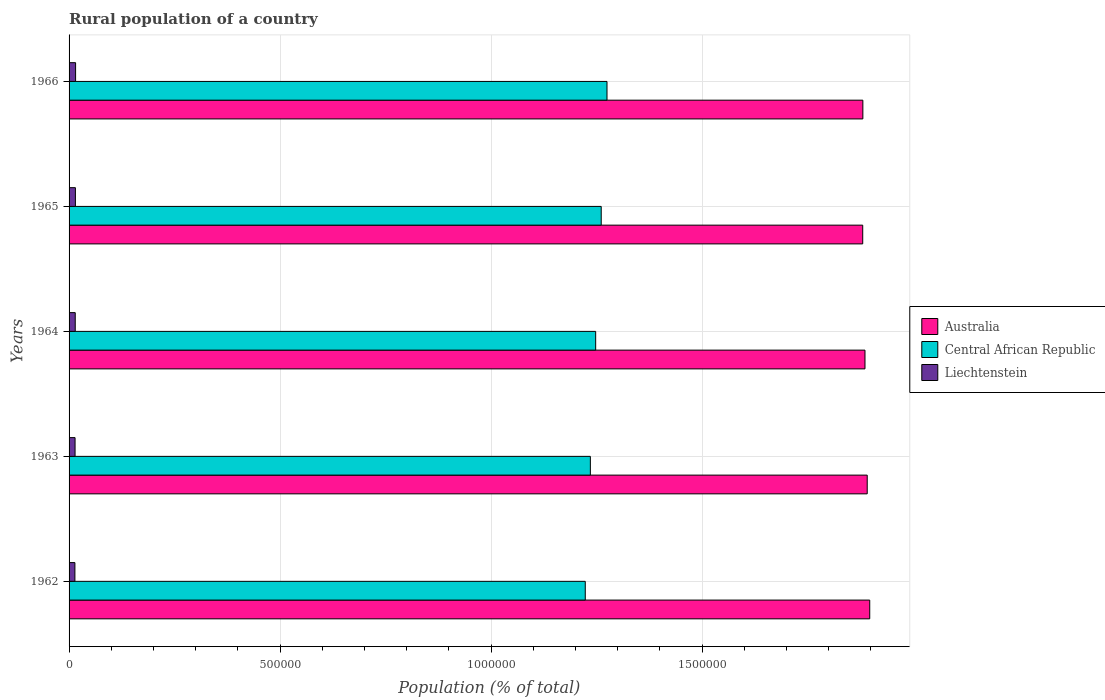How many different coloured bars are there?
Your response must be concise. 3. Are the number of bars per tick equal to the number of legend labels?
Ensure brevity in your answer.  Yes. How many bars are there on the 3rd tick from the bottom?
Your answer should be compact. 3. What is the label of the 2nd group of bars from the top?
Make the answer very short. 1965. In how many cases, is the number of bars for a given year not equal to the number of legend labels?
Offer a very short reply. 0. What is the rural population in Australia in 1966?
Ensure brevity in your answer.  1.88e+06. Across all years, what is the maximum rural population in Central African Republic?
Provide a short and direct response. 1.27e+06. Across all years, what is the minimum rural population in Central African Republic?
Your answer should be compact. 1.22e+06. In which year was the rural population in Central African Republic maximum?
Offer a terse response. 1966. In which year was the rural population in Australia minimum?
Provide a short and direct response. 1965. What is the total rural population in Australia in the graph?
Give a very brief answer. 9.44e+06. What is the difference between the rural population in Central African Republic in 1962 and that in 1966?
Ensure brevity in your answer.  -5.15e+04. What is the difference between the rural population in Liechtenstein in 1966 and the rural population in Australia in 1962?
Your answer should be very brief. -1.88e+06. What is the average rural population in Australia per year?
Keep it short and to the point. 1.89e+06. In the year 1965, what is the difference between the rural population in Australia and rural population in Central African Republic?
Give a very brief answer. 6.20e+05. What is the ratio of the rural population in Central African Republic in 1962 to that in 1965?
Keep it short and to the point. 0.97. Is the rural population in Australia in 1964 less than that in 1965?
Make the answer very short. No. What is the difference between the highest and the second highest rural population in Liechtenstein?
Give a very brief answer. 450. What is the difference between the highest and the lowest rural population in Liechtenstein?
Offer a very short reply. 1645. In how many years, is the rural population in Liechtenstein greater than the average rural population in Liechtenstein taken over all years?
Your answer should be compact. 2. What does the 2nd bar from the top in 1966 represents?
Provide a succinct answer. Central African Republic. What does the 3rd bar from the bottom in 1965 represents?
Make the answer very short. Liechtenstein. How many bars are there?
Give a very brief answer. 15. Are the values on the major ticks of X-axis written in scientific E-notation?
Give a very brief answer. No. Does the graph contain any zero values?
Offer a terse response. No. Does the graph contain grids?
Provide a succinct answer. Yes. Where does the legend appear in the graph?
Provide a succinct answer. Center right. How many legend labels are there?
Your answer should be very brief. 3. How are the legend labels stacked?
Offer a terse response. Vertical. What is the title of the graph?
Make the answer very short. Rural population of a country. Does "Uzbekistan" appear as one of the legend labels in the graph?
Your answer should be very brief. No. What is the label or title of the X-axis?
Give a very brief answer. Population (% of total). What is the Population (% of total) in Australia in 1962?
Ensure brevity in your answer.  1.90e+06. What is the Population (% of total) of Central African Republic in 1962?
Ensure brevity in your answer.  1.22e+06. What is the Population (% of total) in Liechtenstein in 1962?
Offer a very short reply. 1.38e+04. What is the Population (% of total) of Australia in 1963?
Your response must be concise. 1.89e+06. What is the Population (% of total) in Central African Republic in 1963?
Your response must be concise. 1.24e+06. What is the Population (% of total) of Liechtenstein in 1963?
Keep it short and to the point. 1.42e+04. What is the Population (% of total) of Australia in 1964?
Make the answer very short. 1.89e+06. What is the Population (% of total) of Central African Republic in 1964?
Provide a succinct answer. 1.25e+06. What is the Population (% of total) in Liechtenstein in 1964?
Your answer should be compact. 1.46e+04. What is the Population (% of total) of Australia in 1965?
Provide a short and direct response. 1.88e+06. What is the Population (% of total) of Central African Republic in 1965?
Provide a short and direct response. 1.26e+06. What is the Population (% of total) in Liechtenstein in 1965?
Offer a very short reply. 1.50e+04. What is the Population (% of total) of Australia in 1966?
Your answer should be compact. 1.88e+06. What is the Population (% of total) in Central African Republic in 1966?
Provide a succinct answer. 1.27e+06. What is the Population (% of total) of Liechtenstein in 1966?
Offer a very short reply. 1.55e+04. Across all years, what is the maximum Population (% of total) of Australia?
Ensure brevity in your answer.  1.90e+06. Across all years, what is the maximum Population (% of total) in Central African Republic?
Offer a terse response. 1.27e+06. Across all years, what is the maximum Population (% of total) in Liechtenstein?
Offer a very short reply. 1.55e+04. Across all years, what is the minimum Population (% of total) of Australia?
Your response must be concise. 1.88e+06. Across all years, what is the minimum Population (% of total) in Central African Republic?
Your answer should be compact. 1.22e+06. Across all years, what is the minimum Population (% of total) of Liechtenstein?
Your answer should be very brief. 1.38e+04. What is the total Population (% of total) in Australia in the graph?
Offer a very short reply. 9.44e+06. What is the total Population (% of total) in Central African Republic in the graph?
Your response must be concise. 6.24e+06. What is the total Population (% of total) of Liechtenstein in the graph?
Your response must be concise. 7.31e+04. What is the difference between the Population (% of total) of Australia in 1962 and that in 1963?
Your answer should be very brief. 5966. What is the difference between the Population (% of total) of Central African Republic in 1962 and that in 1963?
Provide a short and direct response. -1.21e+04. What is the difference between the Population (% of total) in Liechtenstein in 1962 and that in 1963?
Your answer should be compact. -376. What is the difference between the Population (% of total) in Australia in 1962 and that in 1964?
Your response must be concise. 1.13e+04. What is the difference between the Population (% of total) of Central African Republic in 1962 and that in 1964?
Make the answer very short. -2.46e+04. What is the difference between the Population (% of total) of Liechtenstein in 1962 and that in 1964?
Offer a very short reply. -773. What is the difference between the Population (% of total) of Australia in 1962 and that in 1965?
Your response must be concise. 1.66e+04. What is the difference between the Population (% of total) in Central African Republic in 1962 and that in 1965?
Provide a short and direct response. -3.78e+04. What is the difference between the Population (% of total) of Liechtenstein in 1962 and that in 1965?
Your answer should be very brief. -1195. What is the difference between the Population (% of total) of Australia in 1962 and that in 1966?
Ensure brevity in your answer.  1.63e+04. What is the difference between the Population (% of total) of Central African Republic in 1962 and that in 1966?
Your response must be concise. -5.15e+04. What is the difference between the Population (% of total) in Liechtenstein in 1962 and that in 1966?
Ensure brevity in your answer.  -1645. What is the difference between the Population (% of total) in Australia in 1963 and that in 1964?
Provide a succinct answer. 5287. What is the difference between the Population (% of total) of Central African Republic in 1963 and that in 1964?
Your answer should be very brief. -1.26e+04. What is the difference between the Population (% of total) of Liechtenstein in 1963 and that in 1964?
Your answer should be very brief. -397. What is the difference between the Population (% of total) of Australia in 1963 and that in 1965?
Ensure brevity in your answer.  1.07e+04. What is the difference between the Population (% of total) in Central African Republic in 1963 and that in 1965?
Offer a very short reply. -2.57e+04. What is the difference between the Population (% of total) in Liechtenstein in 1963 and that in 1965?
Provide a succinct answer. -819. What is the difference between the Population (% of total) of Australia in 1963 and that in 1966?
Ensure brevity in your answer.  1.03e+04. What is the difference between the Population (% of total) in Central African Republic in 1963 and that in 1966?
Provide a short and direct response. -3.94e+04. What is the difference between the Population (% of total) of Liechtenstein in 1963 and that in 1966?
Your response must be concise. -1269. What is the difference between the Population (% of total) of Australia in 1964 and that in 1965?
Offer a terse response. 5378. What is the difference between the Population (% of total) of Central African Republic in 1964 and that in 1965?
Make the answer very short. -1.31e+04. What is the difference between the Population (% of total) in Liechtenstein in 1964 and that in 1965?
Keep it short and to the point. -422. What is the difference between the Population (% of total) in Australia in 1964 and that in 1966?
Provide a short and direct response. 5052. What is the difference between the Population (% of total) in Central African Republic in 1964 and that in 1966?
Give a very brief answer. -2.68e+04. What is the difference between the Population (% of total) of Liechtenstein in 1964 and that in 1966?
Provide a short and direct response. -872. What is the difference between the Population (% of total) in Australia in 1965 and that in 1966?
Your answer should be very brief. -326. What is the difference between the Population (% of total) of Central African Republic in 1965 and that in 1966?
Your answer should be very brief. -1.37e+04. What is the difference between the Population (% of total) of Liechtenstein in 1965 and that in 1966?
Keep it short and to the point. -450. What is the difference between the Population (% of total) in Australia in 1962 and the Population (% of total) in Central African Republic in 1963?
Make the answer very short. 6.62e+05. What is the difference between the Population (% of total) of Australia in 1962 and the Population (% of total) of Liechtenstein in 1963?
Your answer should be compact. 1.88e+06. What is the difference between the Population (% of total) in Central African Republic in 1962 and the Population (% of total) in Liechtenstein in 1963?
Your answer should be compact. 1.21e+06. What is the difference between the Population (% of total) of Australia in 1962 and the Population (% of total) of Central African Republic in 1964?
Make the answer very short. 6.49e+05. What is the difference between the Population (% of total) of Australia in 1962 and the Population (% of total) of Liechtenstein in 1964?
Provide a short and direct response. 1.88e+06. What is the difference between the Population (% of total) in Central African Republic in 1962 and the Population (% of total) in Liechtenstein in 1964?
Make the answer very short. 1.21e+06. What is the difference between the Population (% of total) in Australia in 1962 and the Population (% of total) in Central African Republic in 1965?
Your response must be concise. 6.36e+05. What is the difference between the Population (% of total) in Australia in 1962 and the Population (% of total) in Liechtenstein in 1965?
Ensure brevity in your answer.  1.88e+06. What is the difference between the Population (% of total) of Central African Republic in 1962 and the Population (% of total) of Liechtenstein in 1965?
Offer a very short reply. 1.21e+06. What is the difference between the Population (% of total) of Australia in 1962 and the Population (% of total) of Central African Republic in 1966?
Keep it short and to the point. 6.23e+05. What is the difference between the Population (% of total) in Australia in 1962 and the Population (% of total) in Liechtenstein in 1966?
Your answer should be very brief. 1.88e+06. What is the difference between the Population (% of total) of Central African Republic in 1962 and the Population (% of total) of Liechtenstein in 1966?
Offer a terse response. 1.21e+06. What is the difference between the Population (% of total) in Australia in 1963 and the Population (% of total) in Central African Republic in 1964?
Provide a succinct answer. 6.43e+05. What is the difference between the Population (% of total) of Australia in 1963 and the Population (% of total) of Liechtenstein in 1964?
Offer a terse response. 1.88e+06. What is the difference between the Population (% of total) of Central African Republic in 1963 and the Population (% of total) of Liechtenstein in 1964?
Ensure brevity in your answer.  1.22e+06. What is the difference between the Population (% of total) of Australia in 1963 and the Population (% of total) of Central African Republic in 1965?
Provide a short and direct response. 6.30e+05. What is the difference between the Population (% of total) of Australia in 1963 and the Population (% of total) of Liechtenstein in 1965?
Offer a terse response. 1.88e+06. What is the difference between the Population (% of total) in Central African Republic in 1963 and the Population (% of total) in Liechtenstein in 1965?
Offer a terse response. 1.22e+06. What is the difference between the Population (% of total) in Australia in 1963 and the Population (% of total) in Central African Republic in 1966?
Offer a terse response. 6.17e+05. What is the difference between the Population (% of total) of Australia in 1963 and the Population (% of total) of Liechtenstein in 1966?
Give a very brief answer. 1.88e+06. What is the difference between the Population (% of total) in Central African Republic in 1963 and the Population (% of total) in Liechtenstein in 1966?
Your response must be concise. 1.22e+06. What is the difference between the Population (% of total) of Australia in 1964 and the Population (% of total) of Central African Republic in 1965?
Your answer should be compact. 6.25e+05. What is the difference between the Population (% of total) of Australia in 1964 and the Population (% of total) of Liechtenstein in 1965?
Your answer should be compact. 1.87e+06. What is the difference between the Population (% of total) of Central African Republic in 1964 and the Population (% of total) of Liechtenstein in 1965?
Provide a succinct answer. 1.23e+06. What is the difference between the Population (% of total) in Australia in 1964 and the Population (% of total) in Central African Republic in 1966?
Provide a succinct answer. 6.11e+05. What is the difference between the Population (% of total) of Australia in 1964 and the Population (% of total) of Liechtenstein in 1966?
Your answer should be very brief. 1.87e+06. What is the difference between the Population (% of total) of Central African Republic in 1964 and the Population (% of total) of Liechtenstein in 1966?
Keep it short and to the point. 1.23e+06. What is the difference between the Population (% of total) of Australia in 1965 and the Population (% of total) of Central African Republic in 1966?
Provide a succinct answer. 6.06e+05. What is the difference between the Population (% of total) in Australia in 1965 and the Population (% of total) in Liechtenstein in 1966?
Your answer should be very brief. 1.87e+06. What is the difference between the Population (% of total) of Central African Republic in 1965 and the Population (% of total) of Liechtenstein in 1966?
Ensure brevity in your answer.  1.25e+06. What is the average Population (% of total) in Australia per year?
Your answer should be compact. 1.89e+06. What is the average Population (% of total) in Central African Republic per year?
Your answer should be compact. 1.25e+06. What is the average Population (% of total) in Liechtenstein per year?
Ensure brevity in your answer.  1.46e+04. In the year 1962, what is the difference between the Population (% of total) in Australia and Population (% of total) in Central African Republic?
Your response must be concise. 6.74e+05. In the year 1962, what is the difference between the Population (% of total) of Australia and Population (% of total) of Liechtenstein?
Ensure brevity in your answer.  1.88e+06. In the year 1962, what is the difference between the Population (% of total) in Central African Republic and Population (% of total) in Liechtenstein?
Provide a succinct answer. 1.21e+06. In the year 1963, what is the difference between the Population (% of total) in Australia and Population (% of total) in Central African Republic?
Keep it short and to the point. 6.56e+05. In the year 1963, what is the difference between the Population (% of total) in Australia and Population (% of total) in Liechtenstein?
Ensure brevity in your answer.  1.88e+06. In the year 1963, what is the difference between the Population (% of total) in Central African Republic and Population (% of total) in Liechtenstein?
Offer a very short reply. 1.22e+06. In the year 1964, what is the difference between the Population (% of total) of Australia and Population (% of total) of Central African Republic?
Make the answer very short. 6.38e+05. In the year 1964, what is the difference between the Population (% of total) of Australia and Population (% of total) of Liechtenstein?
Provide a short and direct response. 1.87e+06. In the year 1964, what is the difference between the Population (% of total) of Central African Republic and Population (% of total) of Liechtenstein?
Your response must be concise. 1.23e+06. In the year 1965, what is the difference between the Population (% of total) of Australia and Population (% of total) of Central African Republic?
Ensure brevity in your answer.  6.20e+05. In the year 1965, what is the difference between the Population (% of total) of Australia and Population (% of total) of Liechtenstein?
Keep it short and to the point. 1.87e+06. In the year 1965, what is the difference between the Population (% of total) in Central African Republic and Population (% of total) in Liechtenstein?
Provide a succinct answer. 1.25e+06. In the year 1966, what is the difference between the Population (% of total) of Australia and Population (% of total) of Central African Republic?
Your answer should be very brief. 6.06e+05. In the year 1966, what is the difference between the Population (% of total) of Australia and Population (% of total) of Liechtenstein?
Keep it short and to the point. 1.87e+06. In the year 1966, what is the difference between the Population (% of total) in Central African Republic and Population (% of total) in Liechtenstein?
Give a very brief answer. 1.26e+06. What is the ratio of the Population (% of total) of Australia in 1962 to that in 1963?
Make the answer very short. 1. What is the ratio of the Population (% of total) in Central African Republic in 1962 to that in 1963?
Your answer should be compact. 0.99. What is the ratio of the Population (% of total) in Liechtenstein in 1962 to that in 1963?
Keep it short and to the point. 0.97. What is the ratio of the Population (% of total) in Central African Republic in 1962 to that in 1964?
Ensure brevity in your answer.  0.98. What is the ratio of the Population (% of total) of Liechtenstein in 1962 to that in 1964?
Offer a very short reply. 0.95. What is the ratio of the Population (% of total) in Australia in 1962 to that in 1965?
Provide a short and direct response. 1.01. What is the ratio of the Population (% of total) in Liechtenstein in 1962 to that in 1965?
Offer a terse response. 0.92. What is the ratio of the Population (% of total) of Australia in 1962 to that in 1966?
Provide a short and direct response. 1.01. What is the ratio of the Population (% of total) in Central African Republic in 1962 to that in 1966?
Offer a very short reply. 0.96. What is the ratio of the Population (% of total) of Liechtenstein in 1962 to that in 1966?
Your response must be concise. 0.89. What is the ratio of the Population (% of total) in Liechtenstein in 1963 to that in 1964?
Your answer should be compact. 0.97. What is the ratio of the Population (% of total) of Central African Republic in 1963 to that in 1965?
Your answer should be very brief. 0.98. What is the ratio of the Population (% of total) in Liechtenstein in 1963 to that in 1965?
Your answer should be compact. 0.95. What is the ratio of the Population (% of total) of Central African Republic in 1963 to that in 1966?
Keep it short and to the point. 0.97. What is the ratio of the Population (% of total) of Liechtenstein in 1963 to that in 1966?
Ensure brevity in your answer.  0.92. What is the ratio of the Population (% of total) in Liechtenstein in 1964 to that in 1965?
Ensure brevity in your answer.  0.97. What is the ratio of the Population (% of total) in Australia in 1964 to that in 1966?
Keep it short and to the point. 1. What is the ratio of the Population (% of total) in Central African Republic in 1964 to that in 1966?
Offer a terse response. 0.98. What is the ratio of the Population (% of total) in Liechtenstein in 1964 to that in 1966?
Keep it short and to the point. 0.94. What is the ratio of the Population (% of total) in Australia in 1965 to that in 1966?
Ensure brevity in your answer.  1. What is the ratio of the Population (% of total) of Central African Republic in 1965 to that in 1966?
Make the answer very short. 0.99. What is the ratio of the Population (% of total) in Liechtenstein in 1965 to that in 1966?
Offer a very short reply. 0.97. What is the difference between the highest and the second highest Population (% of total) in Australia?
Your answer should be compact. 5966. What is the difference between the highest and the second highest Population (% of total) in Central African Republic?
Offer a very short reply. 1.37e+04. What is the difference between the highest and the second highest Population (% of total) in Liechtenstein?
Make the answer very short. 450. What is the difference between the highest and the lowest Population (% of total) in Australia?
Make the answer very short. 1.66e+04. What is the difference between the highest and the lowest Population (% of total) in Central African Republic?
Keep it short and to the point. 5.15e+04. What is the difference between the highest and the lowest Population (% of total) of Liechtenstein?
Ensure brevity in your answer.  1645. 